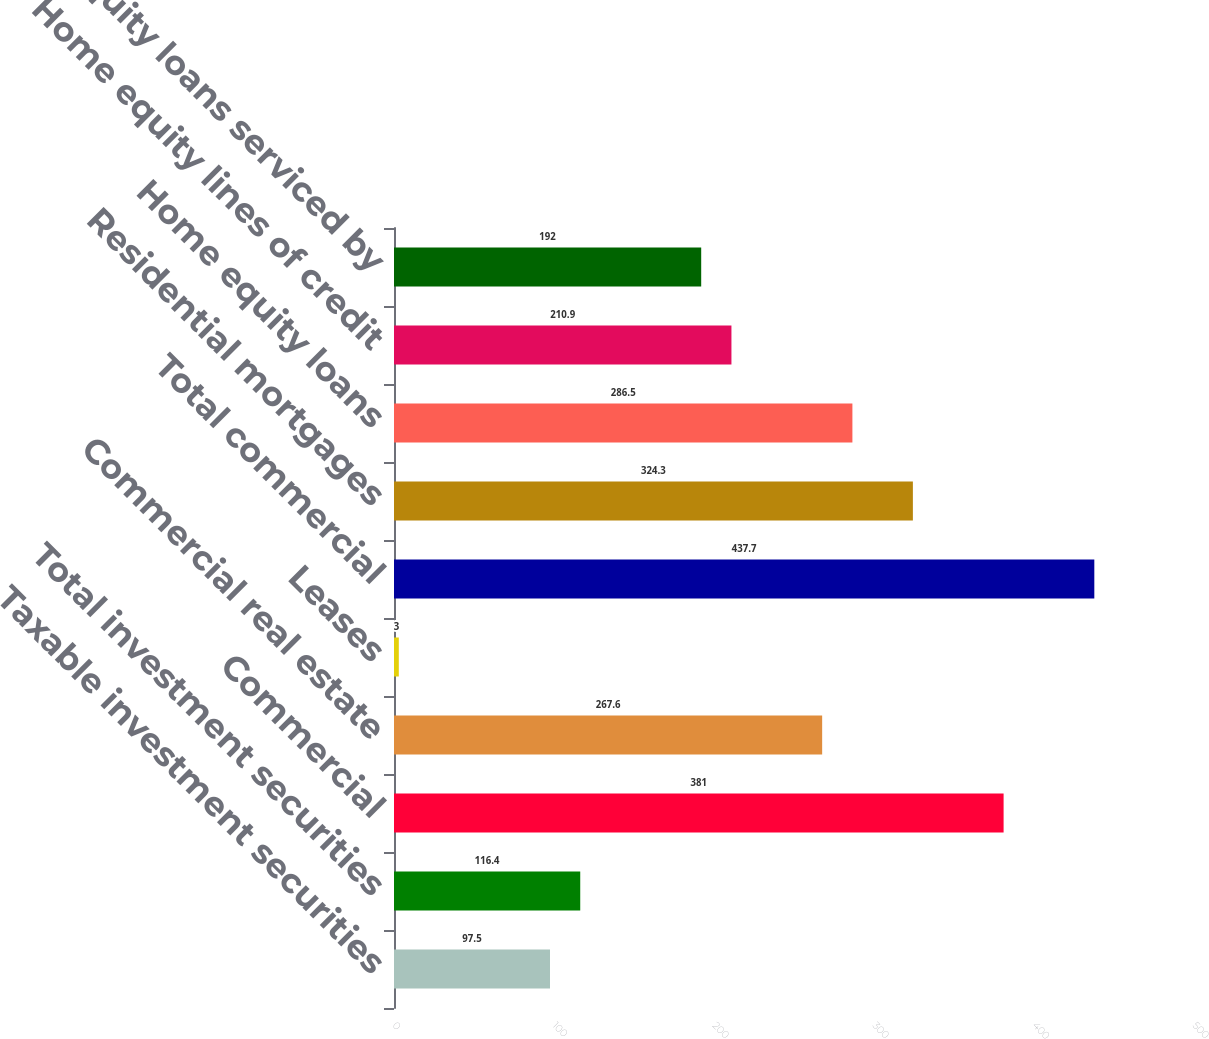Convert chart to OTSL. <chart><loc_0><loc_0><loc_500><loc_500><bar_chart><fcel>Taxable investment securities<fcel>Total investment securities<fcel>Commercial<fcel>Commercial real estate<fcel>Leases<fcel>Total commercial<fcel>Residential mortgages<fcel>Home equity loans<fcel>Home equity lines of credit<fcel>Home equity loans serviced by<nl><fcel>97.5<fcel>116.4<fcel>381<fcel>267.6<fcel>3<fcel>437.7<fcel>324.3<fcel>286.5<fcel>210.9<fcel>192<nl></chart> 